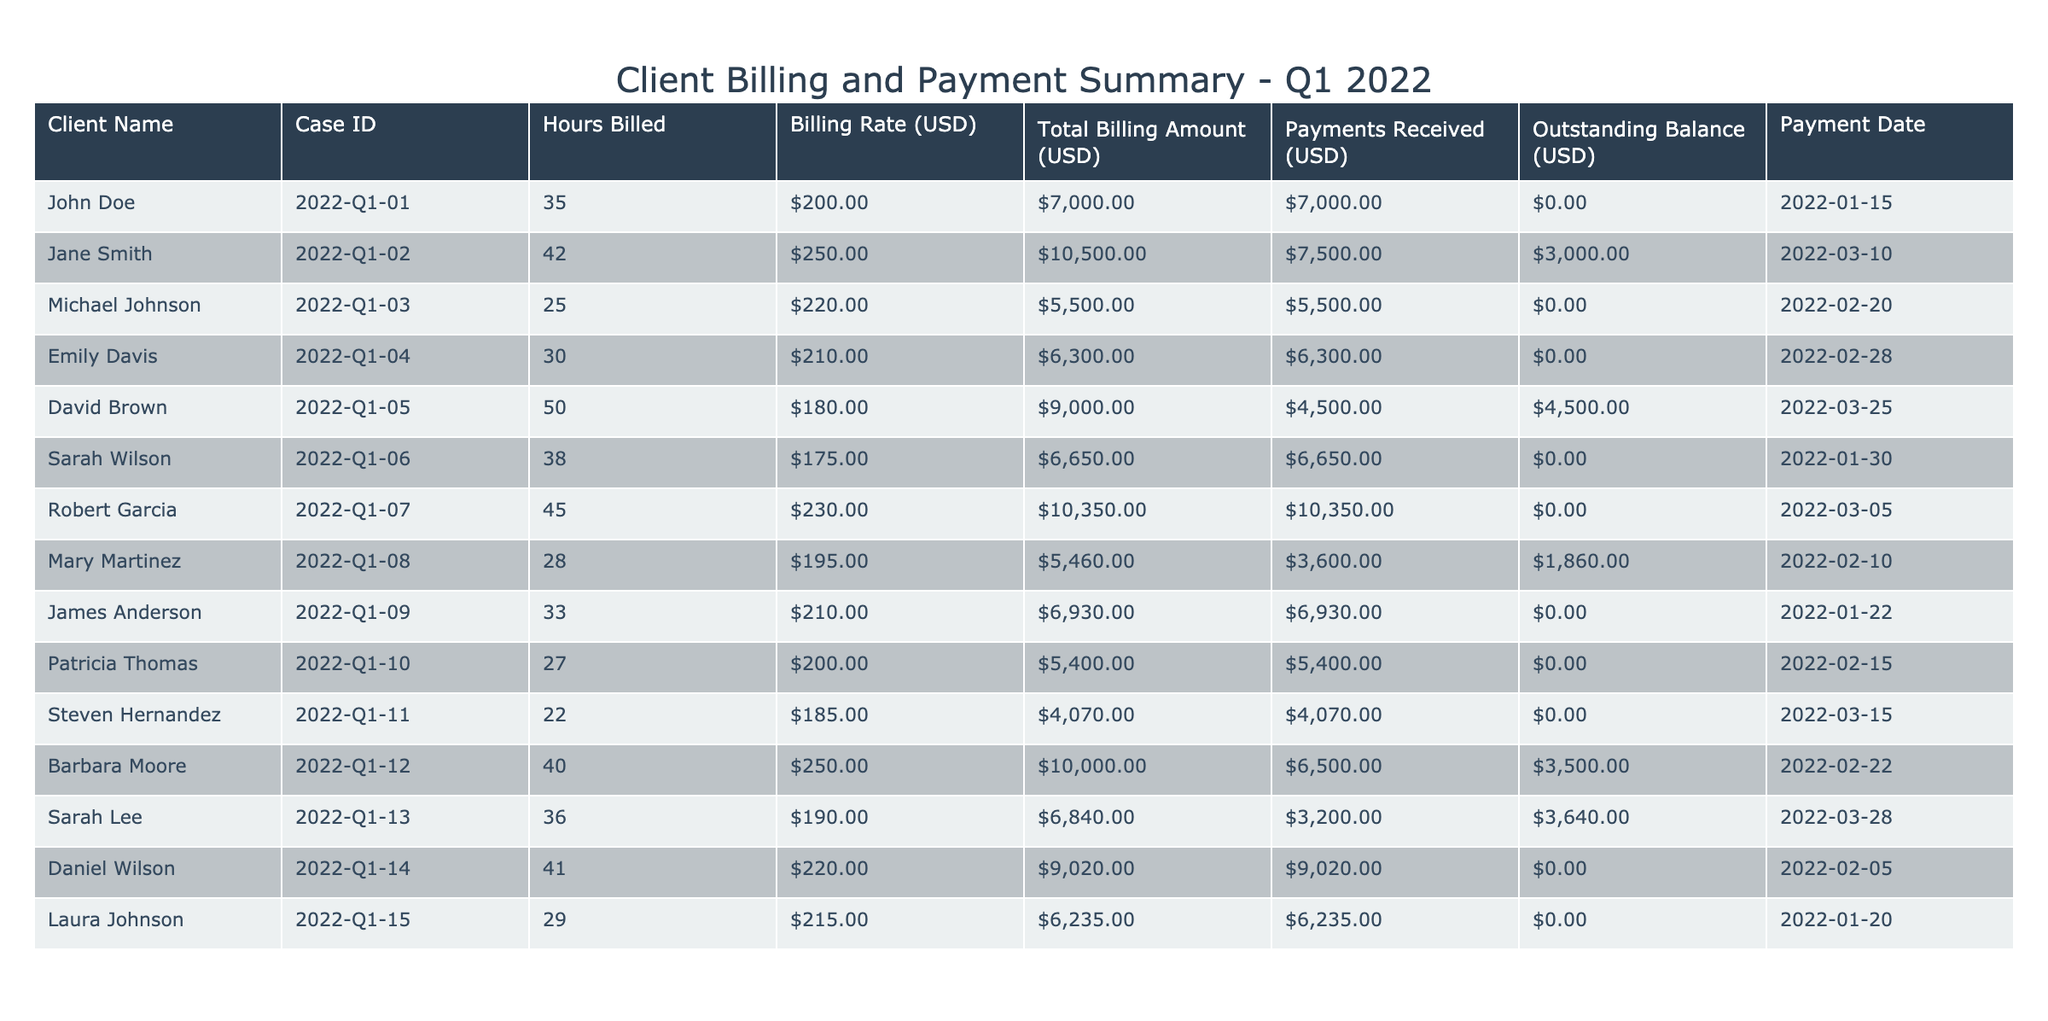What is the total billing amount for John Doe? The total billing amount for John Doe can be found in the "Total Billing Amount (USD)" column corresponding to his case ID. According to the table, it is $7000.
Answer: $7000 How many clients have an outstanding balance? To find the number of clients with an outstanding balance, we should look at the "Outstanding Balance (USD)" column and count the entries greater than zero. In this case, there are 3 clients: Jane Smith, David Brown, and Sarah Lee.
Answer: 3 What is the average billing rate of all clients? To calculate the average billing rate, we first sum the values in the "Billing Rate (USD)" column, which gives us (200 + 250 + 220 + 210 + 180 + 175 + 230 + 195 + 210 + 200 + 185 + 250 + 190 + 220 + 215) = 3,345. There are 15 clients, so we divide the total by 15, yielding an average billing rate of 3,345 / 15 = 223.
Answer: 223 Is there any client who has both received full payment and has an outstanding balance? We analyze the data for clients who have received full payments (meaning their "Outstanding Balance (USD)" is $0). Upon review, all such clients—John Doe, Michael Johnson, Emily Davis, Sarah Wilson, Robert Garcia, James Anderson, Patricia Thomas, Daniel Wilson, and Laura Johnson—do not have outstanding balances. Therefore, the answer is no.
Answer: No Which client has the highest outstanding balance, and what is that amount? To identify the highest outstanding balance, we examine the "Outstanding Balance (USD)" column and look for the maximum value. Upon review, David Brown has the highest outstanding balance of $4500, as he has paid less than the total billing amount.
Answer: $4500 What is the total amount of payments received in Q1 2022? We sum all values in the "Payments Received (USD)" column: 7000 + 7500 + 5500 + 6300 + 4500 + 6650 + 10350 + 3600 + 6930 + 5400 + 4070 + 6500 + 3200 + 9020 + 6235 = 64,205. The total payments received in Q1 2022 amount to $64,205.
Answer: $64,205 How many clients billed less than $7000? We can identify clients with a total billing amount less than $7000 by looking at the "Total Billing Amount (USD)" column. The clients fitting this criteria are Emily Davis ($6300), Mary Martinez ($5460), Patricia Thomas ($5400), Steven Hernandez ($4070), and Sarah Lee ($6840). That totals 5 clients.
Answer: 5 Is the payment date for Sarah Lee later than the payment date for David Brown? We check the "Payment Date" for both clients. Sarah Lee's payment date is March 28, 2022, while David Brown's payment date is March 25, 2022. Since March 28 is later than March 25, the answer is yes.
Answer: Yes 